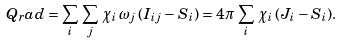Convert formula to latex. <formula><loc_0><loc_0><loc_500><loc_500>Q _ { r } a d = \sum _ { i } \, \sum _ { j } \, \chi _ { i } \, \omega _ { j } \, ( I _ { i j } - S _ { i } ) = 4 \pi \, \sum _ { i } \, \chi _ { i } \, ( J _ { i } - S _ { i } ) .</formula> 